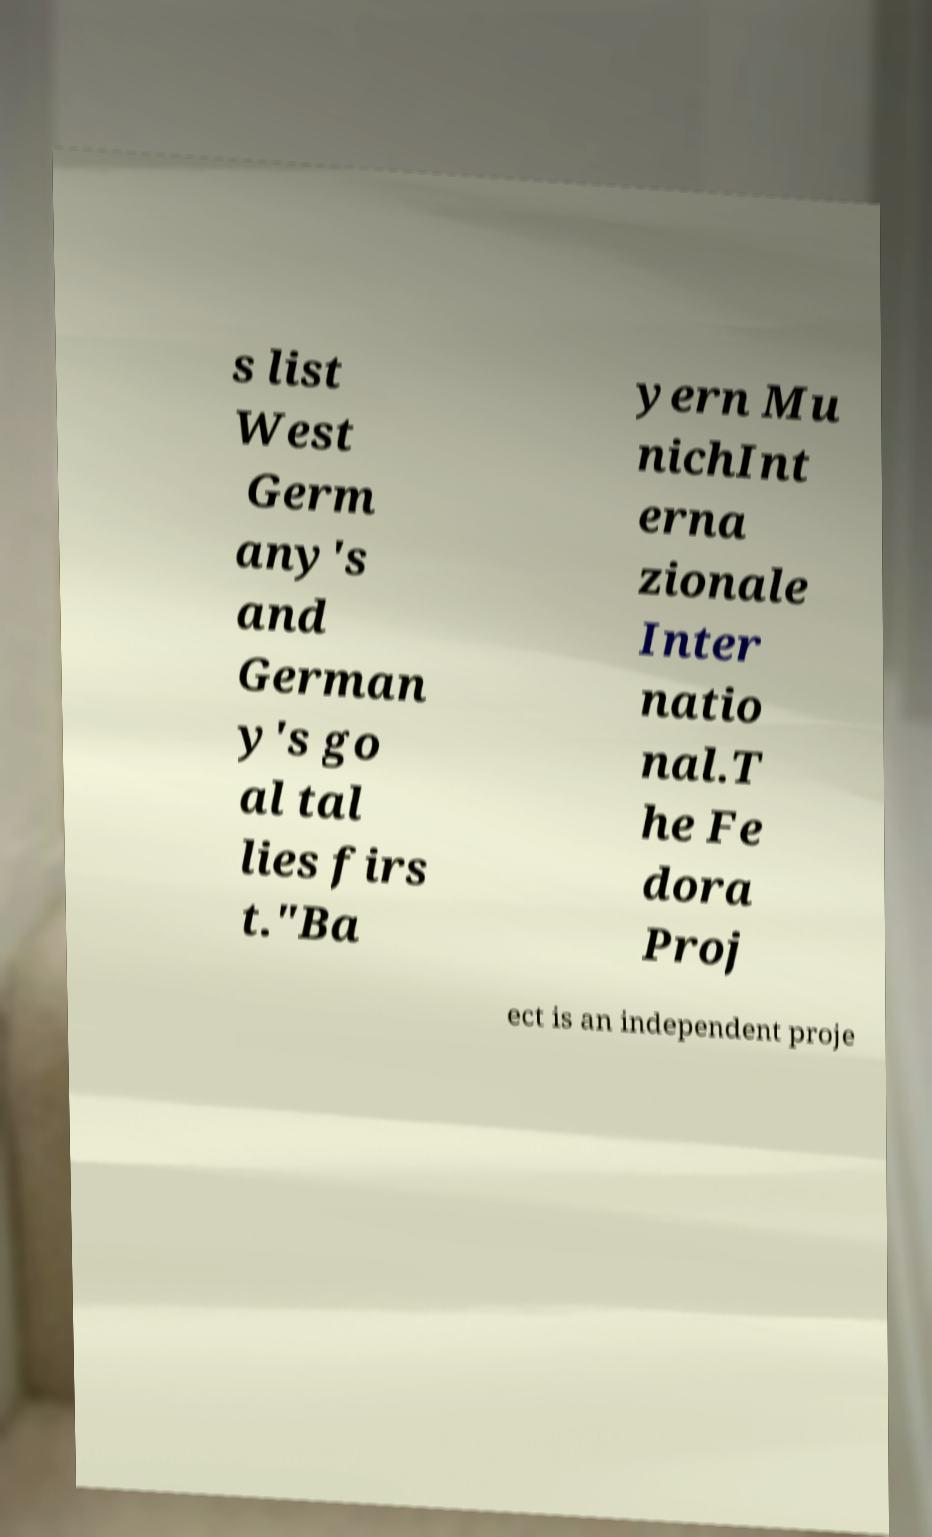Could you assist in decoding the text presented in this image and type it out clearly? s list West Germ any's and German y's go al tal lies firs t."Ba yern Mu nichInt erna zionale Inter natio nal.T he Fe dora Proj ect is an independent proje 